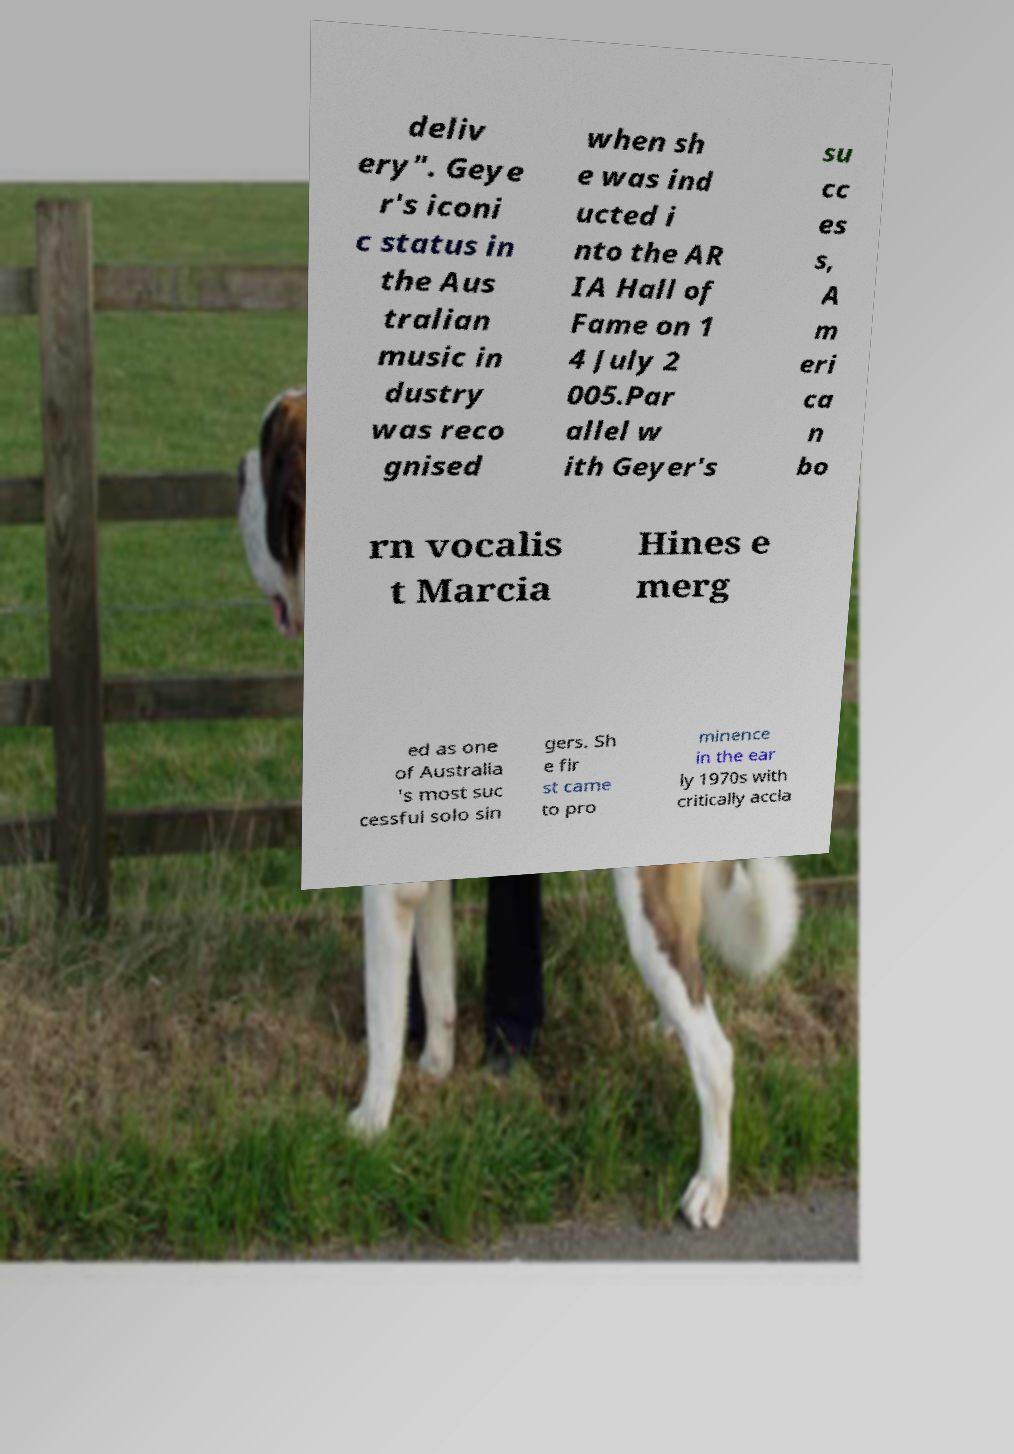Could you extract and type out the text from this image? deliv ery". Geye r's iconi c status in the Aus tralian music in dustry was reco gnised when sh e was ind ucted i nto the AR IA Hall of Fame on 1 4 July 2 005.Par allel w ith Geyer's su cc es s, A m eri ca n bo rn vocalis t Marcia Hines e merg ed as one of Australia 's most suc cessful solo sin gers. Sh e fir st came to pro minence in the ear ly 1970s with critically accla 